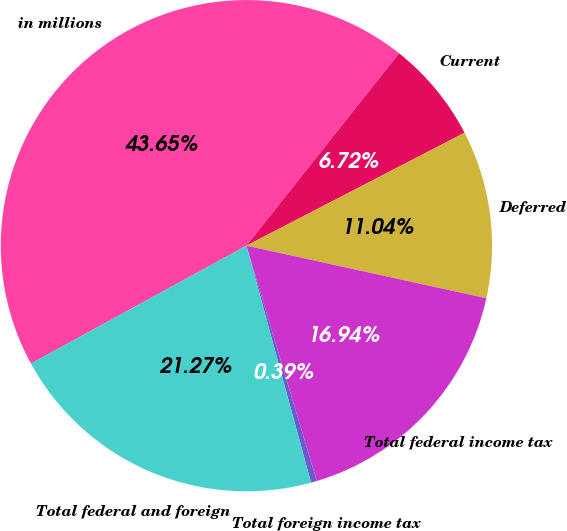Convert chart. <chart><loc_0><loc_0><loc_500><loc_500><pie_chart><fcel>in millions<fcel>Current<fcel>Deferred<fcel>Total federal income tax<fcel>Total foreign income tax<fcel>Total federal and foreign<nl><fcel>43.65%<fcel>6.72%<fcel>11.04%<fcel>16.94%<fcel>0.39%<fcel>21.27%<nl></chart> 